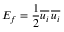<formula> <loc_0><loc_0><loc_500><loc_500>E _ { f } = { \frac { 1 } { 2 } } { \overline { { u _ { i } } } } \, { \overline { { u _ { i } } } }</formula> 